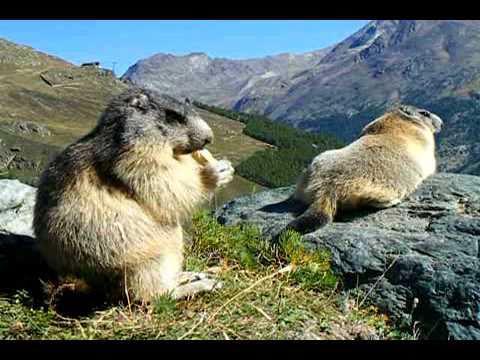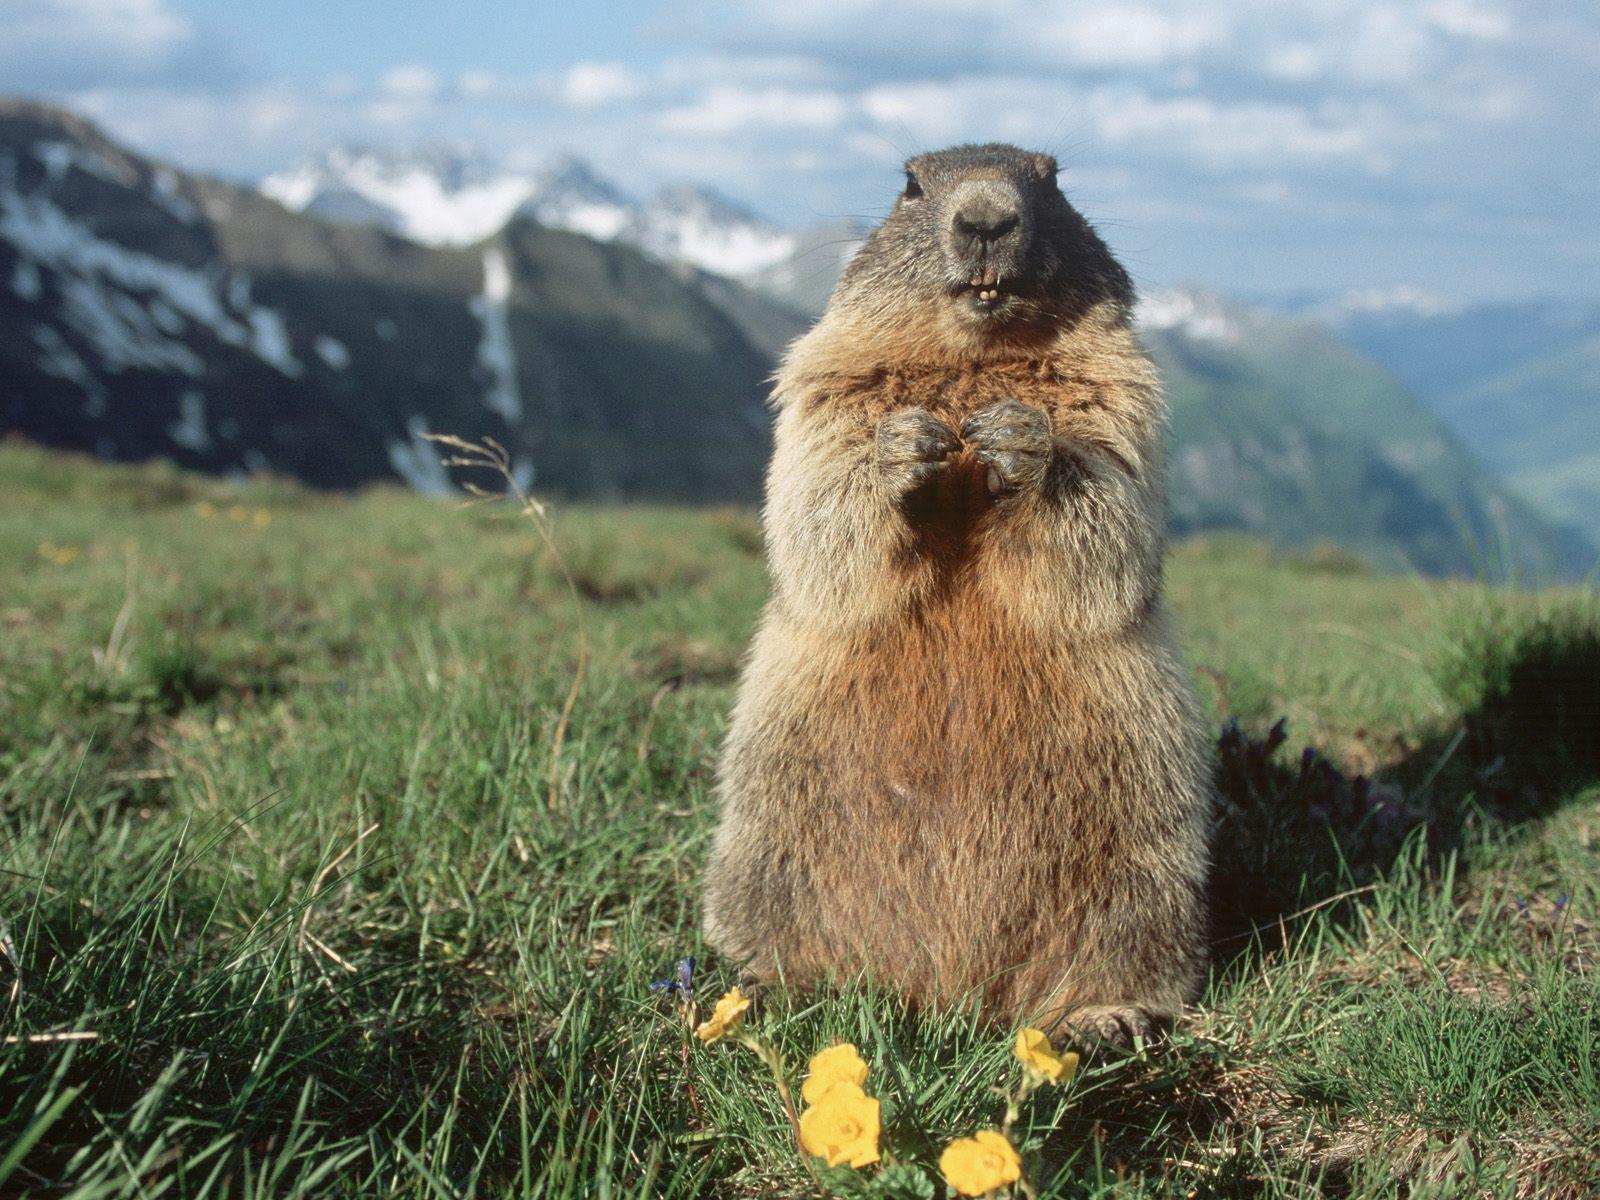The first image is the image on the left, the second image is the image on the right. Given the left and right images, does the statement "There are three marmots" hold true? Answer yes or no. Yes. The first image is the image on the left, the second image is the image on the right. Analyze the images presented: Is the assertion "One image includes exactly twice as many marmots as the other image." valid? Answer yes or no. Yes. 